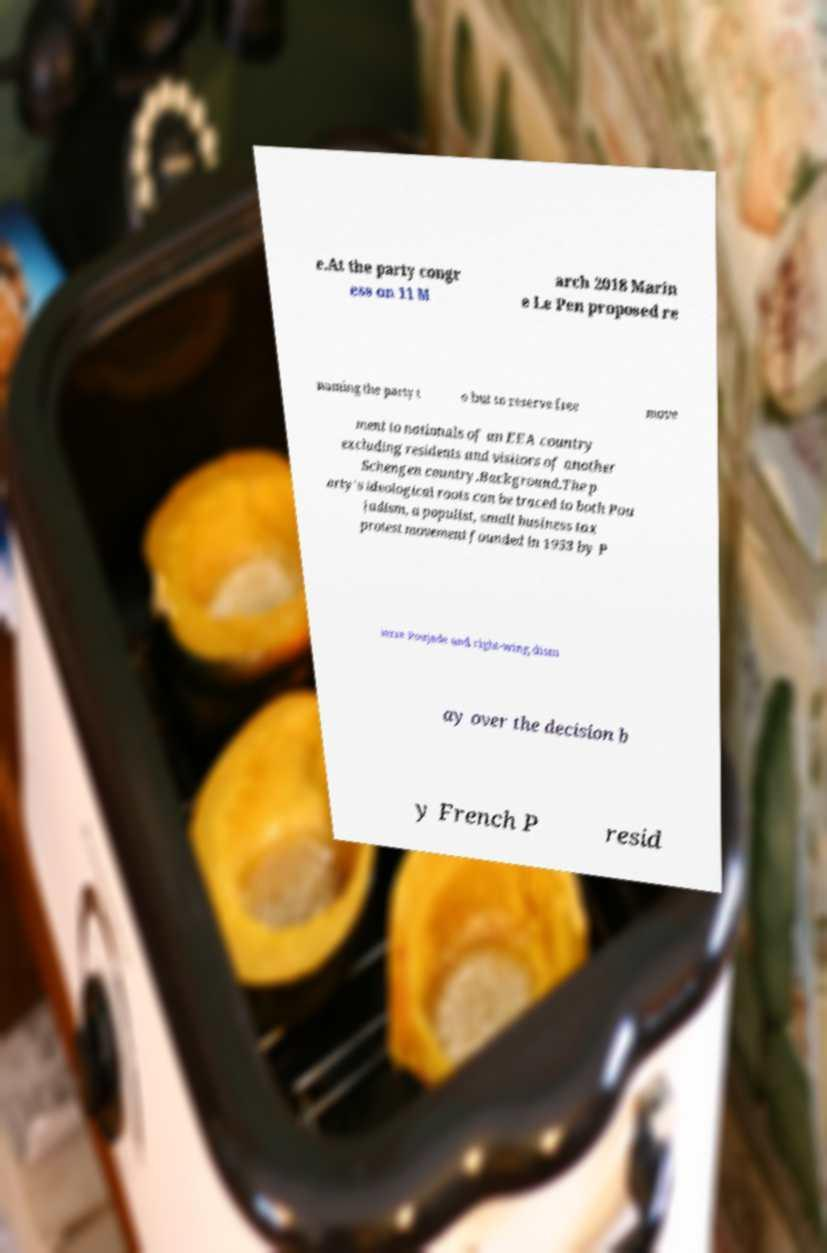What messages or text are displayed in this image? I need them in a readable, typed format. e.At the party congr ess on 11 M arch 2018 Marin e Le Pen proposed re naming the party t o but to reserve free move ment to nationals of an EEA country excluding residents and visitors of another Schengen country.Background.The p arty's ideological roots can be traced to both Pou jadism, a populist, small business tax protest movement founded in 1953 by P ierre Poujade and right-wing dism ay over the decision b y French P resid 